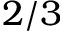<formula> <loc_0><loc_0><loc_500><loc_500>2 / 3</formula> 